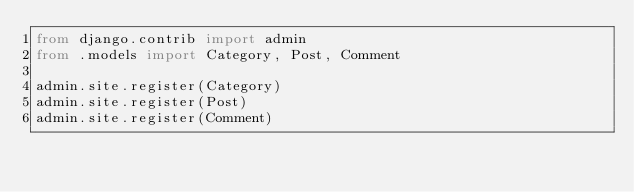<code> <loc_0><loc_0><loc_500><loc_500><_Python_>from django.contrib import admin
from .models import Category, Post, Comment

admin.site.register(Category)
admin.site.register(Post)
admin.site.register(Comment)</code> 